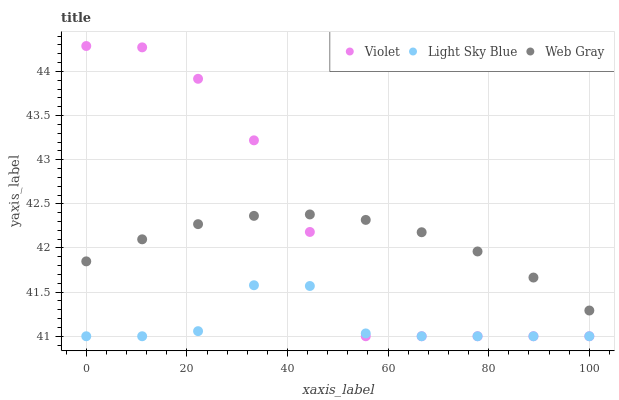Does Light Sky Blue have the minimum area under the curve?
Answer yes or no. Yes. Does Violet have the maximum area under the curve?
Answer yes or no. Yes. Does Web Gray have the minimum area under the curve?
Answer yes or no. No. Does Web Gray have the maximum area under the curve?
Answer yes or no. No. Is Web Gray the smoothest?
Answer yes or no. Yes. Is Violet the roughest?
Answer yes or no. Yes. Is Violet the smoothest?
Answer yes or no. No. Is Web Gray the roughest?
Answer yes or no. No. Does Light Sky Blue have the lowest value?
Answer yes or no. Yes. Does Web Gray have the lowest value?
Answer yes or no. No. Does Violet have the highest value?
Answer yes or no. Yes. Does Web Gray have the highest value?
Answer yes or no. No. Is Light Sky Blue less than Web Gray?
Answer yes or no. Yes. Is Web Gray greater than Light Sky Blue?
Answer yes or no. Yes. Does Light Sky Blue intersect Violet?
Answer yes or no. Yes. Is Light Sky Blue less than Violet?
Answer yes or no. No. Is Light Sky Blue greater than Violet?
Answer yes or no. No. Does Light Sky Blue intersect Web Gray?
Answer yes or no. No. 